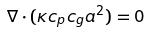Convert formula to latex. <formula><loc_0><loc_0><loc_500><loc_500>\nabla \cdot ( \kappa c _ { p } c _ { g } a ^ { 2 } ) = 0</formula> 